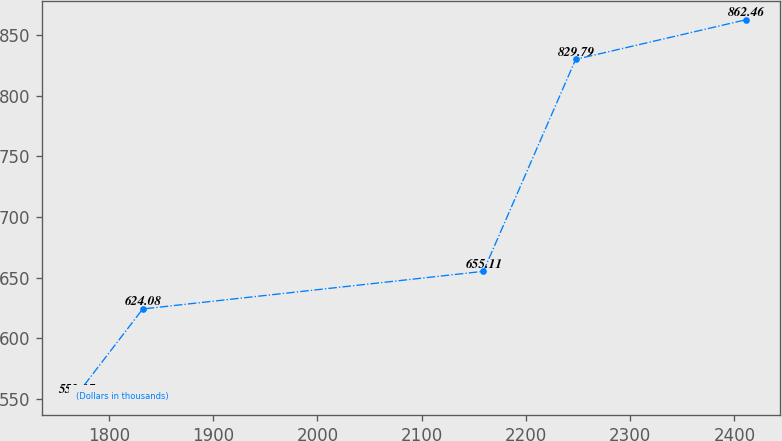Convert chart to OTSL. <chart><loc_0><loc_0><loc_500><loc_500><line_chart><ecel><fcel>(Dollars in thousands)<nl><fcel>1768.23<fcel>552.17<nl><fcel>1832.53<fcel>624.08<nl><fcel>2159.32<fcel>655.11<nl><fcel>2247.79<fcel>829.79<nl><fcel>2411.2<fcel>862.46<nl></chart> 